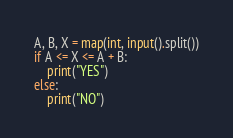<code> <loc_0><loc_0><loc_500><loc_500><_Python_>A, B, X = map(int, input().split())
if A <= X <= A + B:
    print("YES")
else:
    print("NO")
</code> 